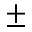<formula> <loc_0><loc_0><loc_500><loc_500>\pm</formula> 